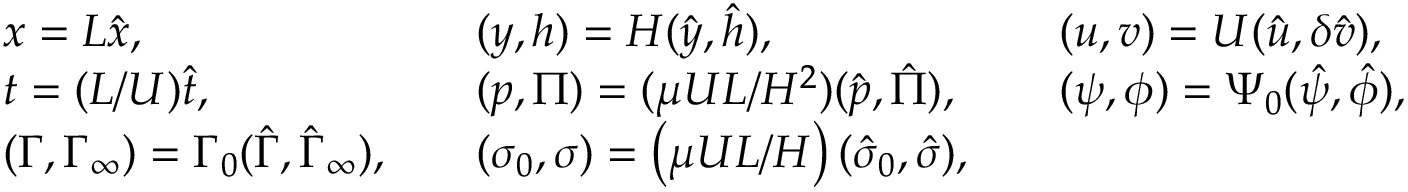Convert formula to latex. <formula><loc_0><loc_0><loc_500><loc_500>\begin{array} { l l l } { x = L \hat { x } , } & { \quad ( y , h ) = H ( \hat { y } , \hat { h } ) , } & { \quad ( u , v ) = U ( \hat { u } , \delta \hat { v } ) , } \\ { t = ( L / U ) \hat { t } , } & { \quad ( p , \Pi ) = ( \mu U L / H ^ { 2 } ) ( \hat { p } , \hat { \Pi } ) , } & { \quad ( \psi , \phi ) = \Psi _ { 0 } ( \hat { \psi } , \hat { \phi } ) , } \\ { ( \Gamma , \Gamma _ { \infty } ) = \Gamma _ { 0 } ( \hat { \Gamma } , \hat { \Gamma } _ { \infty } ) , } & { \quad ( \sigma _ { 0 } , \sigma ) = \left ( \mu U L / H \right ) ( \hat { \sigma } _ { 0 } , \hat { \sigma } ) , } \end{array}</formula> 